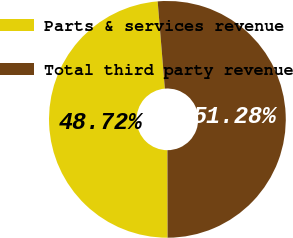Convert chart. <chart><loc_0><loc_0><loc_500><loc_500><pie_chart><fcel>Parts & services revenue<fcel>Total third party revenue<nl><fcel>48.72%<fcel>51.28%<nl></chart> 